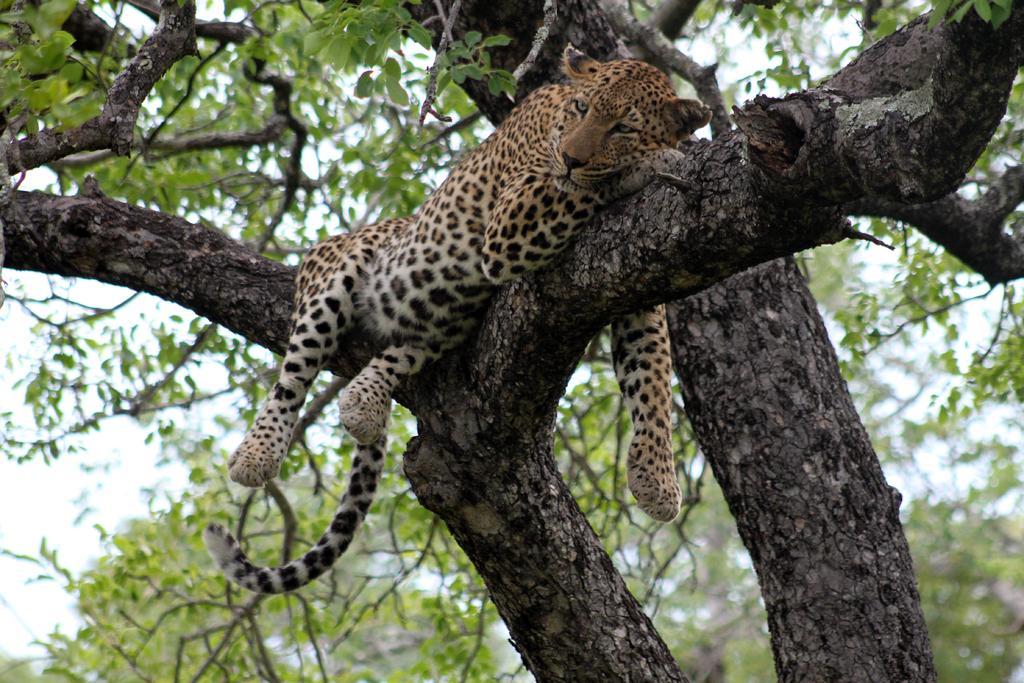In one or two sentences, can you explain what this image depicts? In this image we can see a cheetah on a branch of a tree. In the background we can see branches of trees. Also there is sky. 